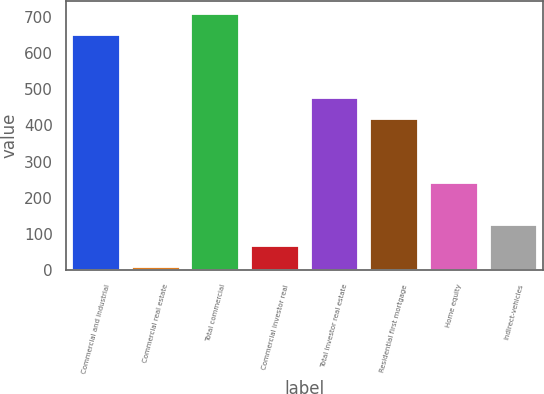<chart> <loc_0><loc_0><loc_500><loc_500><bar_chart><fcel>Commercial and industrial<fcel>Commercial real estate<fcel>Total commercial<fcel>Commercial investor real<fcel>Total investor real estate<fcel>Residential first mortgage<fcel>Home equity<fcel>Indirect-vehicles<nl><fcel>649.2<fcel>9<fcel>707.4<fcel>67.2<fcel>474.6<fcel>416.4<fcel>241.8<fcel>125.4<nl></chart> 